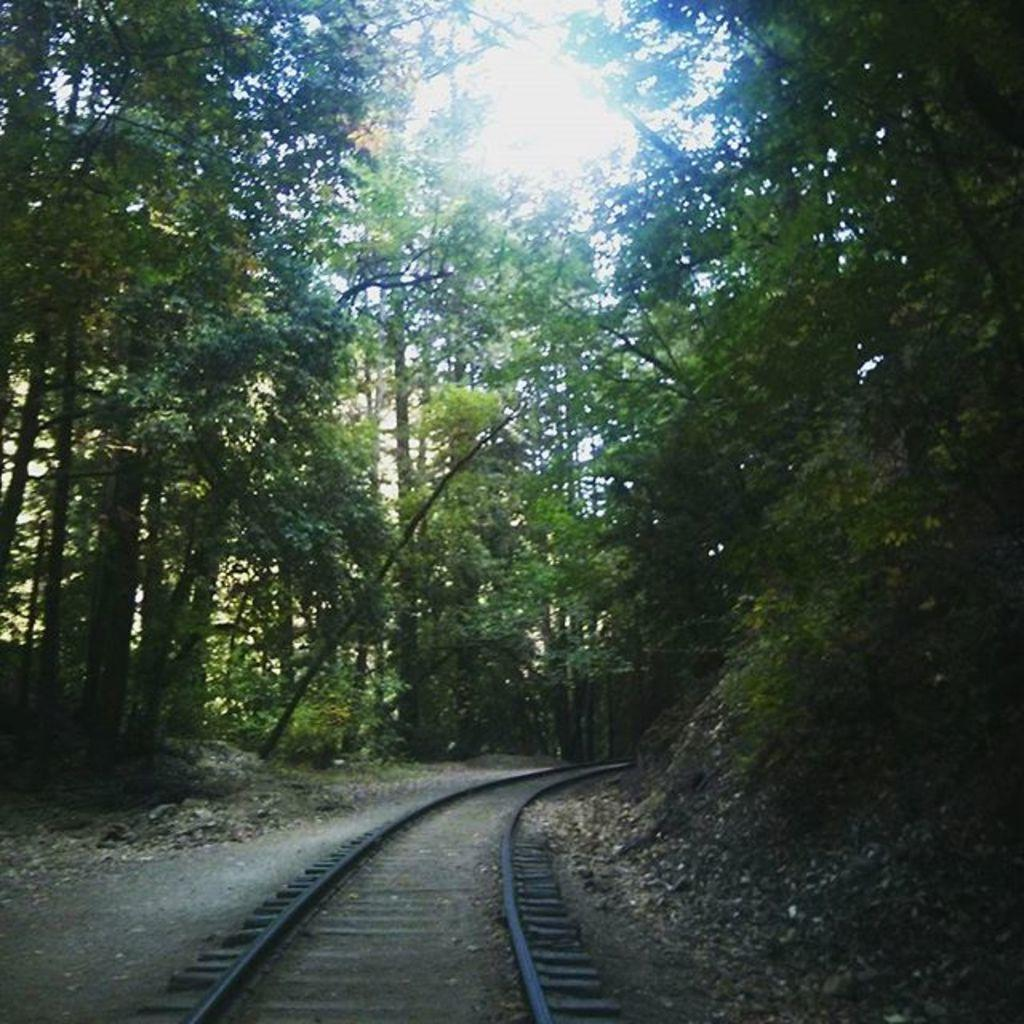What is the main feature of the image? There is a railway track in the image. What type of vegetation can be seen in the image? There are trees and plants in the image. What is visible in the background of the image? The sky is visible in the background of the image. Who is the owner of the jellyfish in the image? There are no jellyfish present in the image. What items are on the list in the image? There is no list present in the image. 